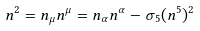<formula> <loc_0><loc_0><loc_500><loc_500>n ^ { 2 } & = n _ { \mu } n ^ { \mu } = n _ { \alpha } n ^ { \alpha } - \sigma _ { 5 } ( n ^ { 5 } ) ^ { 2 } \\</formula> 